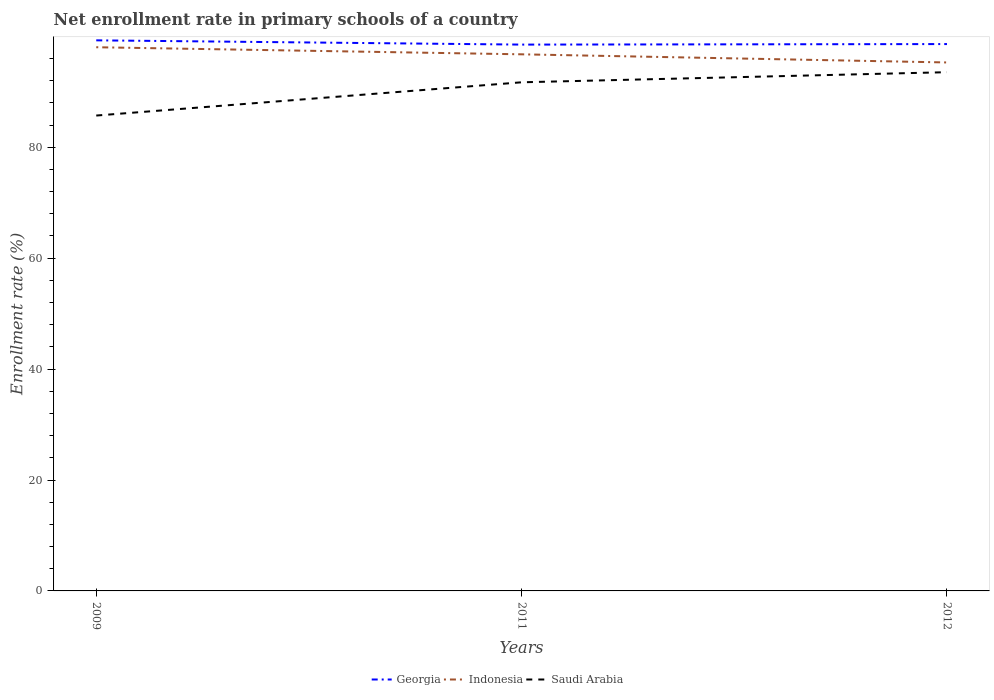How many different coloured lines are there?
Your answer should be very brief. 3. Across all years, what is the maximum enrollment rate in primary schools in Georgia?
Offer a terse response. 98.51. What is the total enrollment rate in primary schools in Georgia in the graph?
Your answer should be compact. -0.1. What is the difference between the highest and the second highest enrollment rate in primary schools in Georgia?
Ensure brevity in your answer.  0.77. What is the difference between the highest and the lowest enrollment rate in primary schools in Georgia?
Provide a short and direct response. 1. Does the graph contain any zero values?
Provide a short and direct response. No. Does the graph contain grids?
Your answer should be compact. No. What is the title of the graph?
Provide a succinct answer. Net enrollment rate in primary schools of a country. What is the label or title of the Y-axis?
Provide a succinct answer. Enrollment rate (%). What is the Enrollment rate (%) in Georgia in 2009?
Provide a succinct answer. 99.28. What is the Enrollment rate (%) of Indonesia in 2009?
Give a very brief answer. 98.04. What is the Enrollment rate (%) in Saudi Arabia in 2009?
Offer a very short reply. 85.72. What is the Enrollment rate (%) of Georgia in 2011?
Ensure brevity in your answer.  98.51. What is the Enrollment rate (%) of Indonesia in 2011?
Provide a succinct answer. 96.76. What is the Enrollment rate (%) of Saudi Arabia in 2011?
Provide a succinct answer. 91.71. What is the Enrollment rate (%) in Georgia in 2012?
Offer a terse response. 98.61. What is the Enrollment rate (%) in Indonesia in 2012?
Your answer should be very brief. 95.29. What is the Enrollment rate (%) of Saudi Arabia in 2012?
Your answer should be compact. 93.54. Across all years, what is the maximum Enrollment rate (%) of Georgia?
Your answer should be compact. 99.28. Across all years, what is the maximum Enrollment rate (%) in Indonesia?
Offer a very short reply. 98.04. Across all years, what is the maximum Enrollment rate (%) of Saudi Arabia?
Your response must be concise. 93.54. Across all years, what is the minimum Enrollment rate (%) of Georgia?
Provide a short and direct response. 98.51. Across all years, what is the minimum Enrollment rate (%) in Indonesia?
Offer a very short reply. 95.29. Across all years, what is the minimum Enrollment rate (%) of Saudi Arabia?
Ensure brevity in your answer.  85.72. What is the total Enrollment rate (%) of Georgia in the graph?
Offer a very short reply. 296.4. What is the total Enrollment rate (%) in Indonesia in the graph?
Provide a short and direct response. 290.08. What is the total Enrollment rate (%) of Saudi Arabia in the graph?
Give a very brief answer. 270.97. What is the difference between the Enrollment rate (%) in Georgia in 2009 and that in 2011?
Give a very brief answer. 0.77. What is the difference between the Enrollment rate (%) of Indonesia in 2009 and that in 2011?
Your answer should be compact. 1.28. What is the difference between the Enrollment rate (%) in Saudi Arabia in 2009 and that in 2011?
Offer a very short reply. -6. What is the difference between the Enrollment rate (%) in Georgia in 2009 and that in 2012?
Give a very brief answer. 0.67. What is the difference between the Enrollment rate (%) of Indonesia in 2009 and that in 2012?
Offer a terse response. 2.74. What is the difference between the Enrollment rate (%) in Saudi Arabia in 2009 and that in 2012?
Make the answer very short. -7.82. What is the difference between the Enrollment rate (%) in Georgia in 2011 and that in 2012?
Your answer should be compact. -0.1. What is the difference between the Enrollment rate (%) of Indonesia in 2011 and that in 2012?
Keep it short and to the point. 1.47. What is the difference between the Enrollment rate (%) in Saudi Arabia in 2011 and that in 2012?
Keep it short and to the point. -1.82. What is the difference between the Enrollment rate (%) in Georgia in 2009 and the Enrollment rate (%) in Indonesia in 2011?
Provide a short and direct response. 2.52. What is the difference between the Enrollment rate (%) of Georgia in 2009 and the Enrollment rate (%) of Saudi Arabia in 2011?
Provide a short and direct response. 7.57. What is the difference between the Enrollment rate (%) in Indonesia in 2009 and the Enrollment rate (%) in Saudi Arabia in 2011?
Provide a succinct answer. 6.32. What is the difference between the Enrollment rate (%) in Georgia in 2009 and the Enrollment rate (%) in Indonesia in 2012?
Provide a succinct answer. 3.99. What is the difference between the Enrollment rate (%) in Georgia in 2009 and the Enrollment rate (%) in Saudi Arabia in 2012?
Provide a succinct answer. 5.74. What is the difference between the Enrollment rate (%) of Indonesia in 2009 and the Enrollment rate (%) of Saudi Arabia in 2012?
Keep it short and to the point. 4.5. What is the difference between the Enrollment rate (%) in Georgia in 2011 and the Enrollment rate (%) in Indonesia in 2012?
Provide a succinct answer. 3.22. What is the difference between the Enrollment rate (%) of Georgia in 2011 and the Enrollment rate (%) of Saudi Arabia in 2012?
Keep it short and to the point. 4.98. What is the difference between the Enrollment rate (%) of Indonesia in 2011 and the Enrollment rate (%) of Saudi Arabia in 2012?
Provide a succinct answer. 3.22. What is the average Enrollment rate (%) in Georgia per year?
Your answer should be compact. 98.8. What is the average Enrollment rate (%) in Indonesia per year?
Provide a short and direct response. 96.69. What is the average Enrollment rate (%) of Saudi Arabia per year?
Your answer should be compact. 90.32. In the year 2009, what is the difference between the Enrollment rate (%) in Georgia and Enrollment rate (%) in Indonesia?
Ensure brevity in your answer.  1.24. In the year 2009, what is the difference between the Enrollment rate (%) in Georgia and Enrollment rate (%) in Saudi Arabia?
Provide a succinct answer. 13.56. In the year 2009, what is the difference between the Enrollment rate (%) in Indonesia and Enrollment rate (%) in Saudi Arabia?
Provide a succinct answer. 12.32. In the year 2011, what is the difference between the Enrollment rate (%) in Georgia and Enrollment rate (%) in Indonesia?
Give a very brief answer. 1.75. In the year 2011, what is the difference between the Enrollment rate (%) in Georgia and Enrollment rate (%) in Saudi Arabia?
Give a very brief answer. 6.8. In the year 2011, what is the difference between the Enrollment rate (%) in Indonesia and Enrollment rate (%) in Saudi Arabia?
Keep it short and to the point. 5.04. In the year 2012, what is the difference between the Enrollment rate (%) in Georgia and Enrollment rate (%) in Indonesia?
Provide a succinct answer. 3.32. In the year 2012, what is the difference between the Enrollment rate (%) of Georgia and Enrollment rate (%) of Saudi Arabia?
Make the answer very short. 5.07. In the year 2012, what is the difference between the Enrollment rate (%) in Indonesia and Enrollment rate (%) in Saudi Arabia?
Give a very brief answer. 1.76. What is the ratio of the Enrollment rate (%) of Indonesia in 2009 to that in 2011?
Provide a succinct answer. 1.01. What is the ratio of the Enrollment rate (%) in Saudi Arabia in 2009 to that in 2011?
Your response must be concise. 0.93. What is the ratio of the Enrollment rate (%) of Georgia in 2009 to that in 2012?
Your answer should be compact. 1.01. What is the ratio of the Enrollment rate (%) of Indonesia in 2009 to that in 2012?
Keep it short and to the point. 1.03. What is the ratio of the Enrollment rate (%) of Saudi Arabia in 2009 to that in 2012?
Your answer should be very brief. 0.92. What is the ratio of the Enrollment rate (%) of Georgia in 2011 to that in 2012?
Make the answer very short. 1. What is the ratio of the Enrollment rate (%) of Indonesia in 2011 to that in 2012?
Keep it short and to the point. 1.02. What is the ratio of the Enrollment rate (%) of Saudi Arabia in 2011 to that in 2012?
Make the answer very short. 0.98. What is the difference between the highest and the second highest Enrollment rate (%) of Georgia?
Offer a terse response. 0.67. What is the difference between the highest and the second highest Enrollment rate (%) in Indonesia?
Offer a terse response. 1.28. What is the difference between the highest and the second highest Enrollment rate (%) in Saudi Arabia?
Provide a succinct answer. 1.82. What is the difference between the highest and the lowest Enrollment rate (%) of Georgia?
Provide a short and direct response. 0.77. What is the difference between the highest and the lowest Enrollment rate (%) of Indonesia?
Offer a terse response. 2.74. What is the difference between the highest and the lowest Enrollment rate (%) in Saudi Arabia?
Provide a succinct answer. 7.82. 